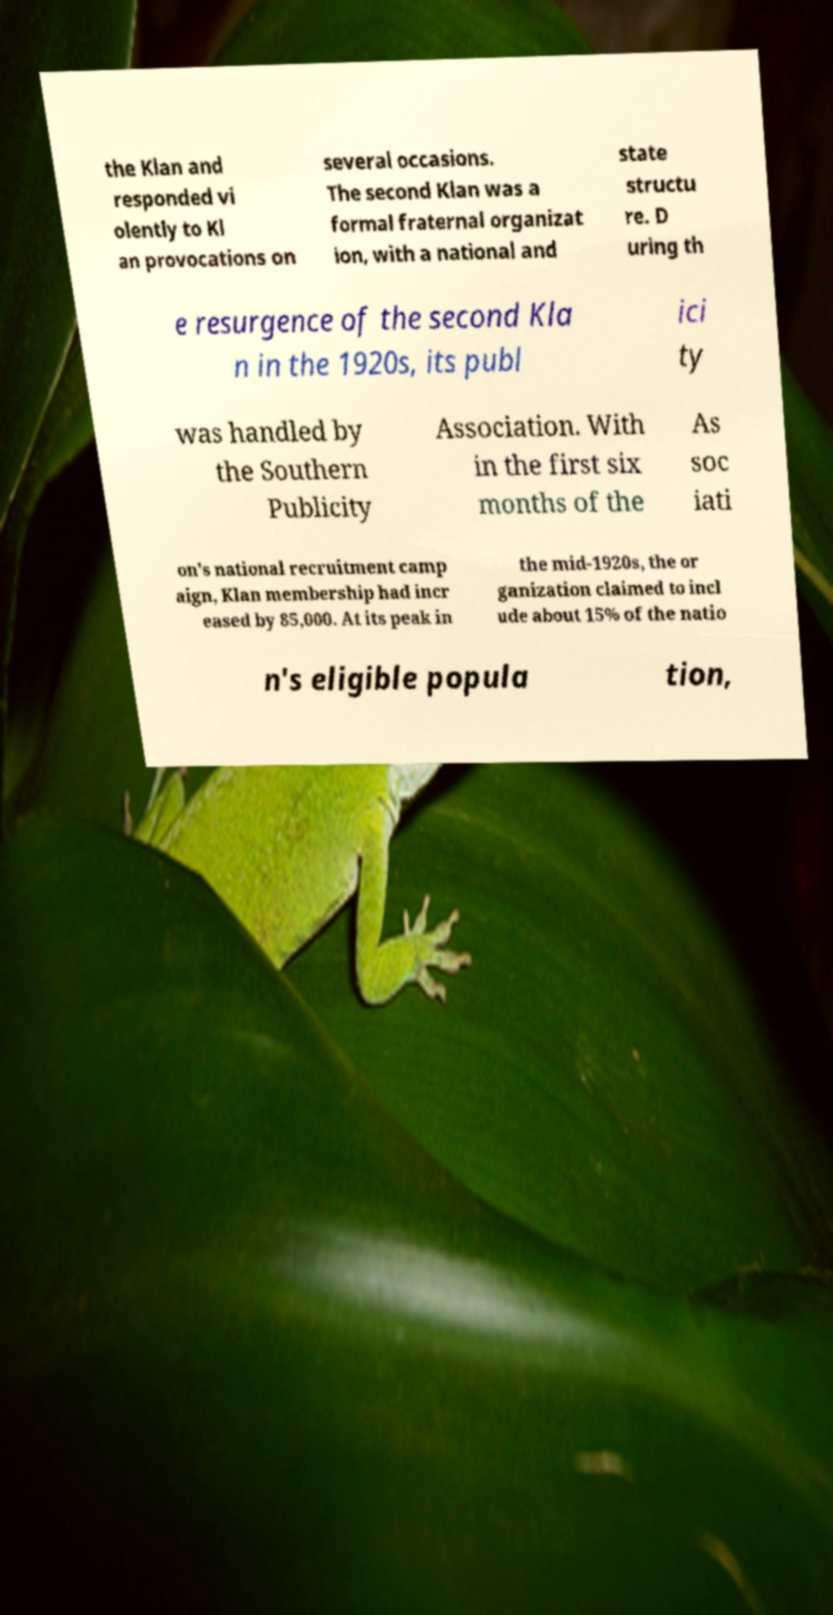For documentation purposes, I need the text within this image transcribed. Could you provide that? the Klan and responded vi olently to Kl an provocations on several occasions. The second Klan was a formal fraternal organizat ion, with a national and state structu re. D uring th e resurgence of the second Kla n in the 1920s, its publ ici ty was handled by the Southern Publicity Association. With in the first six months of the As soc iati on's national recruitment camp aign, Klan membership had incr eased by 85,000. At its peak in the mid-1920s, the or ganization claimed to incl ude about 15% of the natio n's eligible popula tion, 